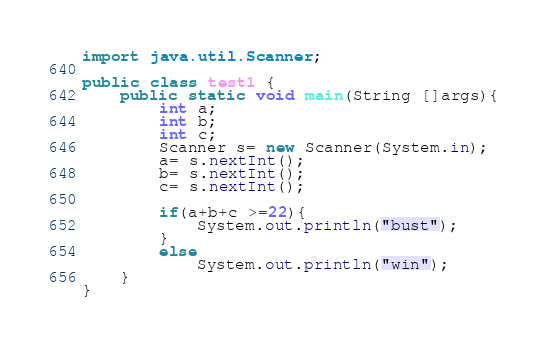<code> <loc_0><loc_0><loc_500><loc_500><_Java_>import java.util.Scanner;

public class test1 {
    public static void main(String []args){
        int a;
        int b;
        int c;
        Scanner s= new Scanner(System.in);
        a= s.nextInt();
        b= s.nextInt();
        c= s.nextInt();

        if(a+b+c >=22){
            System.out.println("bust");
        }
        else
            System.out.println("win");
    }
}</code> 